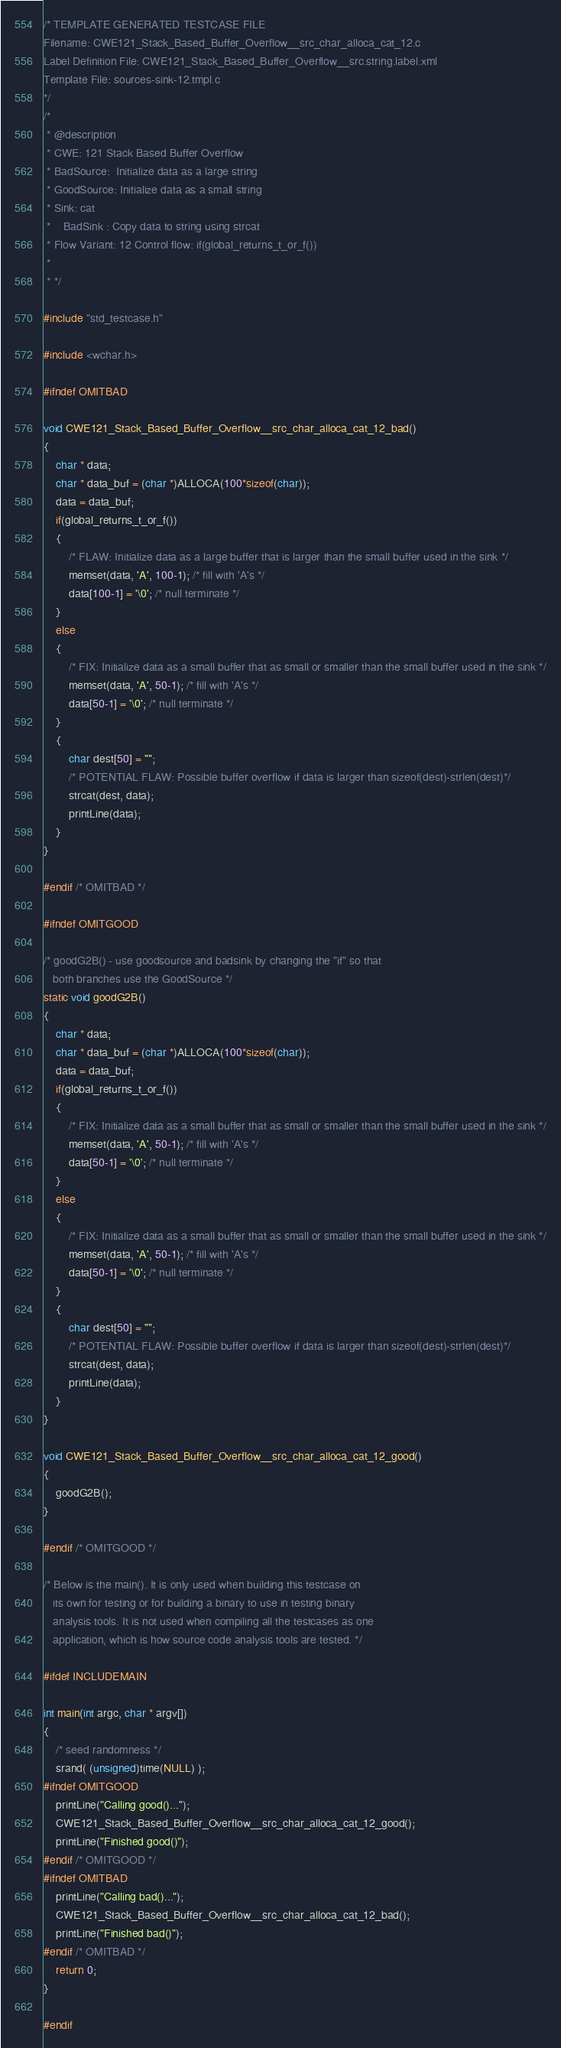<code> <loc_0><loc_0><loc_500><loc_500><_C_>/* TEMPLATE GENERATED TESTCASE FILE
Filename: CWE121_Stack_Based_Buffer_Overflow__src_char_alloca_cat_12.c
Label Definition File: CWE121_Stack_Based_Buffer_Overflow__src.string.label.xml
Template File: sources-sink-12.tmpl.c
*/
/*
 * @description
 * CWE: 121 Stack Based Buffer Overflow
 * BadSource:  Initialize data as a large string
 * GoodSource: Initialize data as a small string
 * Sink: cat
 *    BadSink : Copy data to string using strcat
 * Flow Variant: 12 Control flow: if(global_returns_t_or_f())
 *
 * */

#include "std_testcase.h"

#include <wchar.h>

#ifndef OMITBAD

void CWE121_Stack_Based_Buffer_Overflow__src_char_alloca_cat_12_bad()
{
    char * data;
    char * data_buf = (char *)ALLOCA(100*sizeof(char));
    data = data_buf;
    if(global_returns_t_or_f())
    {
        /* FLAW: Initialize data as a large buffer that is larger than the small buffer used in the sink */
        memset(data, 'A', 100-1); /* fill with 'A's */
        data[100-1] = '\0'; /* null terminate */
    }
    else
    {
        /* FIX: Initialize data as a small buffer that as small or smaller than the small buffer used in the sink */
        memset(data, 'A', 50-1); /* fill with 'A's */
        data[50-1] = '\0'; /* null terminate */
    }
    {
        char dest[50] = "";
        /* POTENTIAL FLAW: Possible buffer overflow if data is larger than sizeof(dest)-strlen(dest)*/
        strcat(dest, data);
        printLine(data);
    }
}

#endif /* OMITBAD */

#ifndef OMITGOOD

/* goodG2B() - use goodsource and badsink by changing the "if" so that
   both branches use the GoodSource */
static void goodG2B()
{
    char * data;
    char * data_buf = (char *)ALLOCA(100*sizeof(char));
    data = data_buf;
    if(global_returns_t_or_f())
    {
        /* FIX: Initialize data as a small buffer that as small or smaller than the small buffer used in the sink */
        memset(data, 'A', 50-1); /* fill with 'A's */
        data[50-1] = '\0'; /* null terminate */
    }
    else
    {
        /* FIX: Initialize data as a small buffer that as small or smaller than the small buffer used in the sink */
        memset(data, 'A', 50-1); /* fill with 'A's */
        data[50-1] = '\0'; /* null terminate */
    }
    {
        char dest[50] = "";
        /* POTENTIAL FLAW: Possible buffer overflow if data is larger than sizeof(dest)-strlen(dest)*/
        strcat(dest, data);
        printLine(data);
    }
}

void CWE121_Stack_Based_Buffer_Overflow__src_char_alloca_cat_12_good()
{
    goodG2B();
}

#endif /* OMITGOOD */

/* Below is the main(). It is only used when building this testcase on
   its own for testing or for building a binary to use in testing binary
   analysis tools. It is not used when compiling all the testcases as one
   application, which is how source code analysis tools are tested. */

#ifdef INCLUDEMAIN

int main(int argc, char * argv[])
{
    /* seed randomness */
    srand( (unsigned)time(NULL) );
#ifndef OMITGOOD
    printLine("Calling good()...");
    CWE121_Stack_Based_Buffer_Overflow__src_char_alloca_cat_12_good();
    printLine("Finished good()");
#endif /* OMITGOOD */
#ifndef OMITBAD
    printLine("Calling bad()...");
    CWE121_Stack_Based_Buffer_Overflow__src_char_alloca_cat_12_bad();
    printLine("Finished bad()");
#endif /* OMITBAD */
    return 0;
}

#endif
</code> 